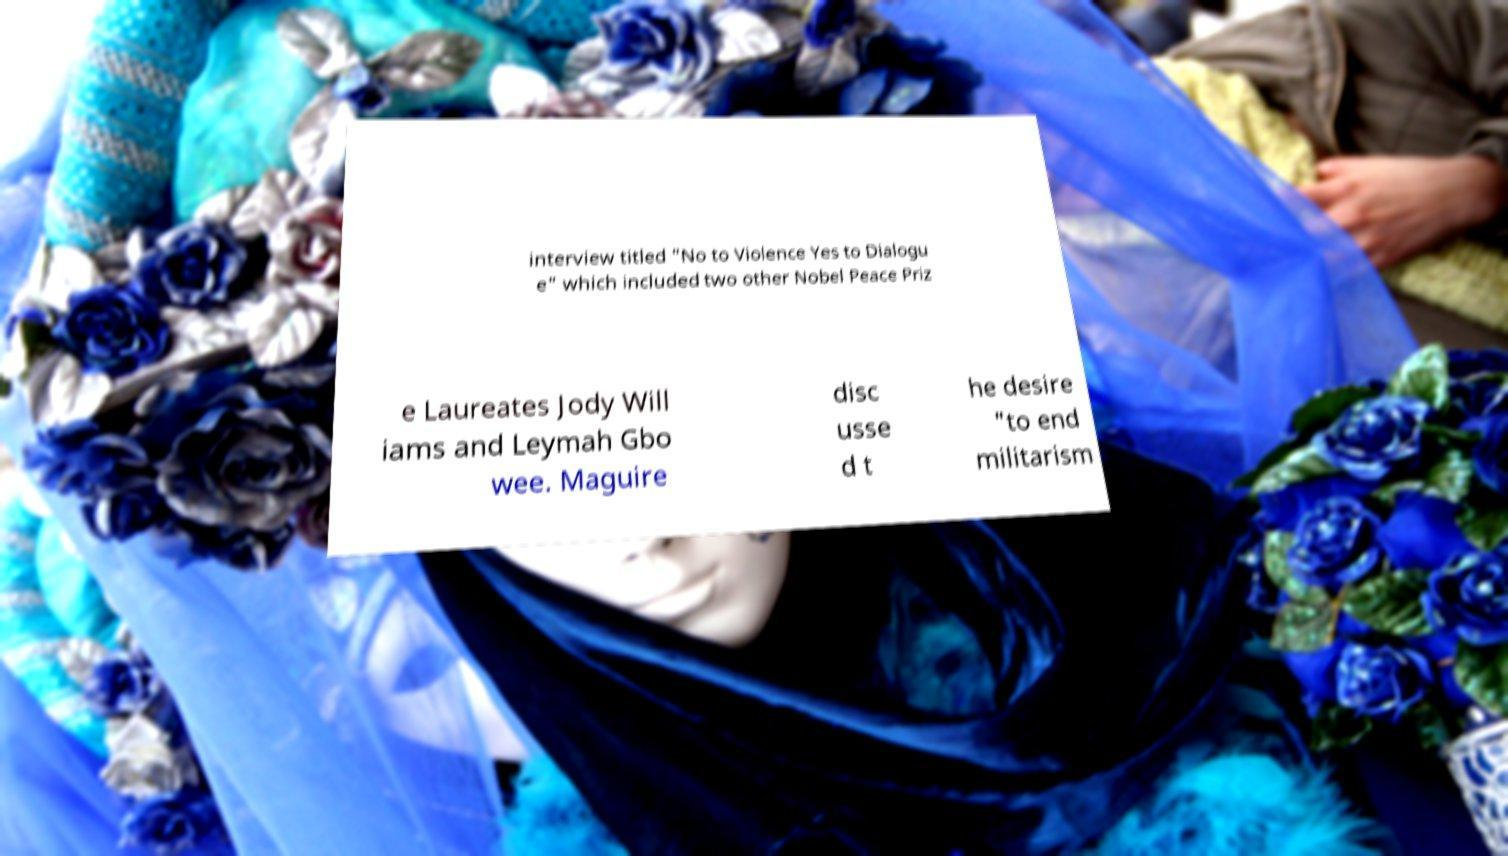Could you extract and type out the text from this image? interview titled "No to Violence Yes to Dialogu e" which included two other Nobel Peace Priz e Laureates Jody Will iams and Leymah Gbo wee. Maguire disc usse d t he desire "to end militarism 